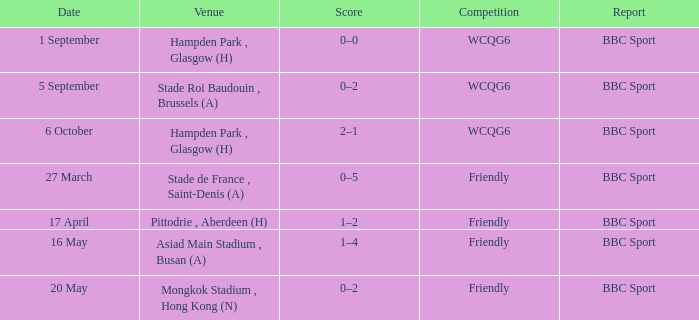Can you give me this table as a dict? {'header': ['Date', 'Venue', 'Score', 'Competition', 'Report'], 'rows': [['1 September', 'Hampden Park , Glasgow (H)', '0–0', 'WCQG6', 'BBC Sport'], ['5 September', 'Stade Roi Baudouin , Brussels (A)', '0–2', 'WCQG6', 'BBC Sport'], ['6 October', 'Hampden Park , Glasgow (H)', '2–1', 'WCQG6', 'BBC Sport'], ['27 March', 'Stade de France , Saint-Denis (A)', '0–5', 'Friendly', 'BBC Sport'], ['17 April', 'Pittodrie , Aberdeen (H)', '1–2', 'Friendly', 'BBC Sport'], ['16 May', 'Asiad Main Stadium , Busan (A)', '1–4', 'Friendly', 'BBC Sport'], ['20 May', 'Mongkok Stadium , Hong Kong (N)', '0–2', 'Friendly', 'BBC Sport']]} What was the score of the game on 1 september? 0–0. 